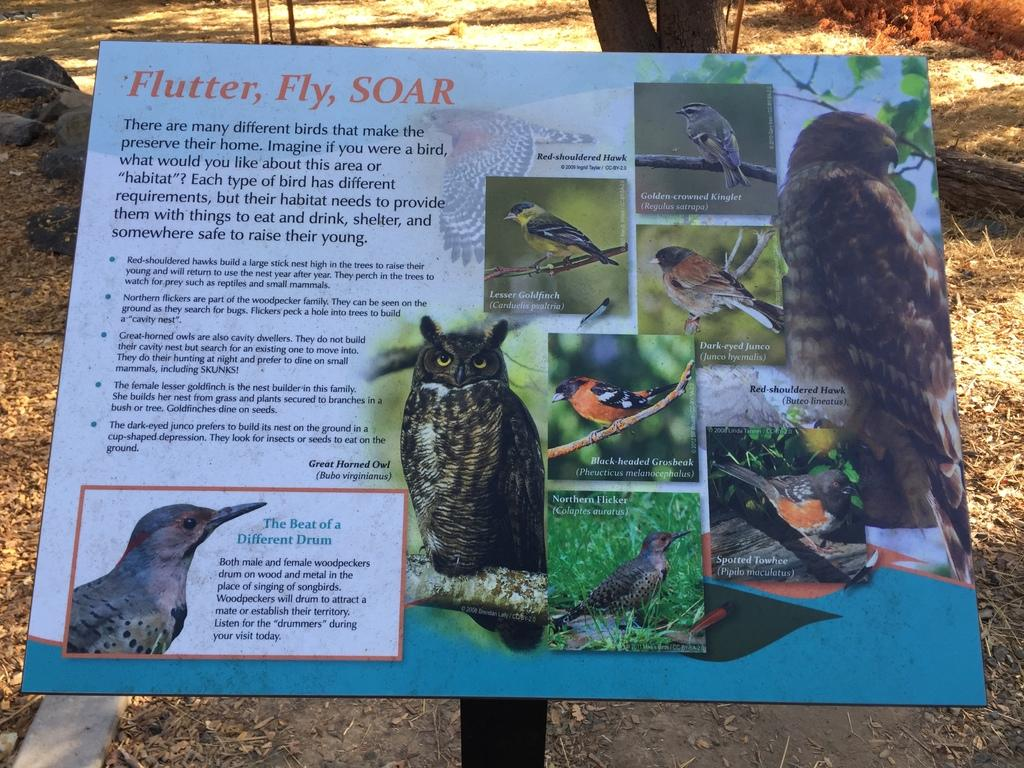Where was the picture taken? The picture was taken outside. What is the main subject in the center of the image? There is a poster in the center of the image. What can be found on the poster? The poster contains text and pictures of birds. What type of natural environment is visible in the background of the image? There is grass and rocks in the background of the image. Are there any other items visible in the background of the image? Yes, there are other items visible in the background of the image. What type of silverware is being used in the protest shown in the image? There is no protest or silverware present in the image; it features a poster with text and pictures of birds in an outdoor setting. 